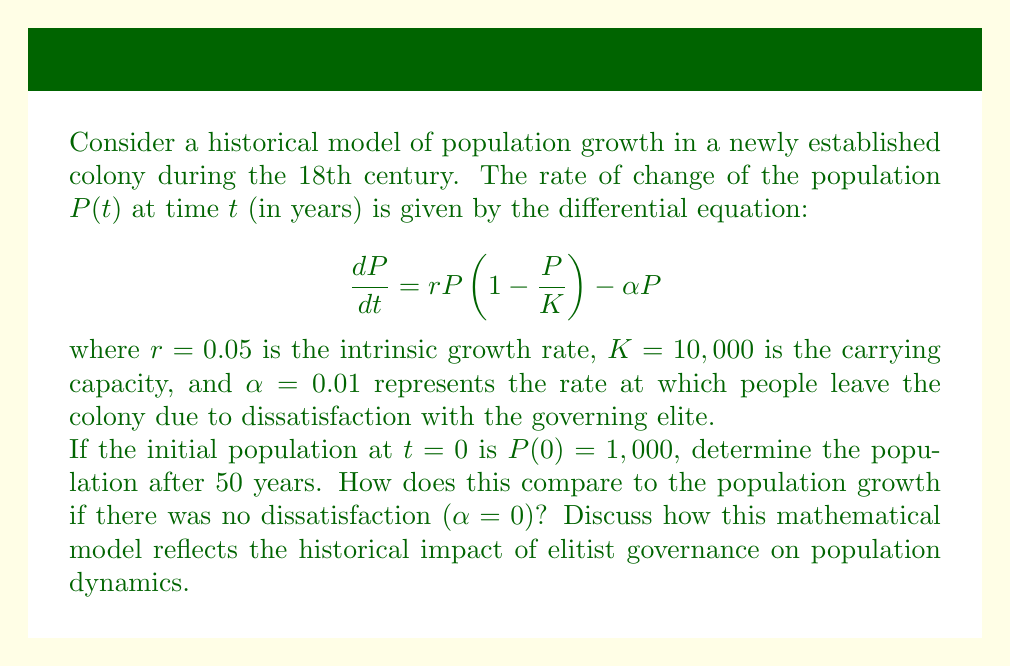Can you answer this question? To solve this problem, we need to use numerical methods as the differential equation is nonlinear. We'll use the fourth-order Runge-Kutta method to approximate the solution.

1) First, let's define our function $f(P, t)$:

   $$ f(P, t) = rP\left(1 - \frac{P}{K}\right) - \alpha P = 0.05P\left(1 - \frac{P}{10000}\right) - 0.01P $$

2) Now, we'll implement the Runge-Kutta method with a step size of $h = 0.1$ years:

   For $i = 0$ to $499$:
   $$ k_1 = hf(P_i, t_i) $$
   $$ k_2 = hf(P_i + \frac{k_1}{2}, t_i + \frac{h}{2}) $$
   $$ k_3 = hf(P_i + \frac{k_2}{2}, t_i + \frac{h}{2}) $$
   $$ k_4 = hf(P_i + k_3, t_i + h) $$
   $$ P_{i+1} = P_i + \frac{1}{6}(k_1 + 2k_2 + 2k_3 + k_4) $$

3) After implementing this method (which would typically be done using a computer), we find that after 50 years (500 steps), the population is approximately 3,947.

4) If we set $\alpha = 0$ and repeat the process, we find that the population after 50 years would be approximately 5,813.

5) The difference between these two results (3,947 vs 5,813) demonstrates the significant impact of dissatisfaction with the governing elite on population growth.

From a historical perspective, this model reflects how elitist governance can impede population growth in a colony. The term $\alpha P$ in the differential equation represents the rate at which people leave the colony due to dissatisfaction, which could be caused by policies that favor the elite at the expense of the general population. This mathematical representation aligns with historical observations of how poor governance and lack of popular representation can lead to slower growth or even decline in colonial populations.

The model also shows how populist movements might arise in response to such governance. The significant difference in population growth between the two scenarios ($\alpha = 0.01$ vs $\alpha = 0$) could represent the potential for rapid growth that is being suppressed by elitist policies, providing fuel for populist arguments against the governing elite.
Answer: The population after 50 years is approximately 3,947. Without dissatisfaction ($\alpha = 0$), the population would be approximately 5,813. The difference of 1,866 people represents the historical impact of elitist governance on population dynamics in this model. 